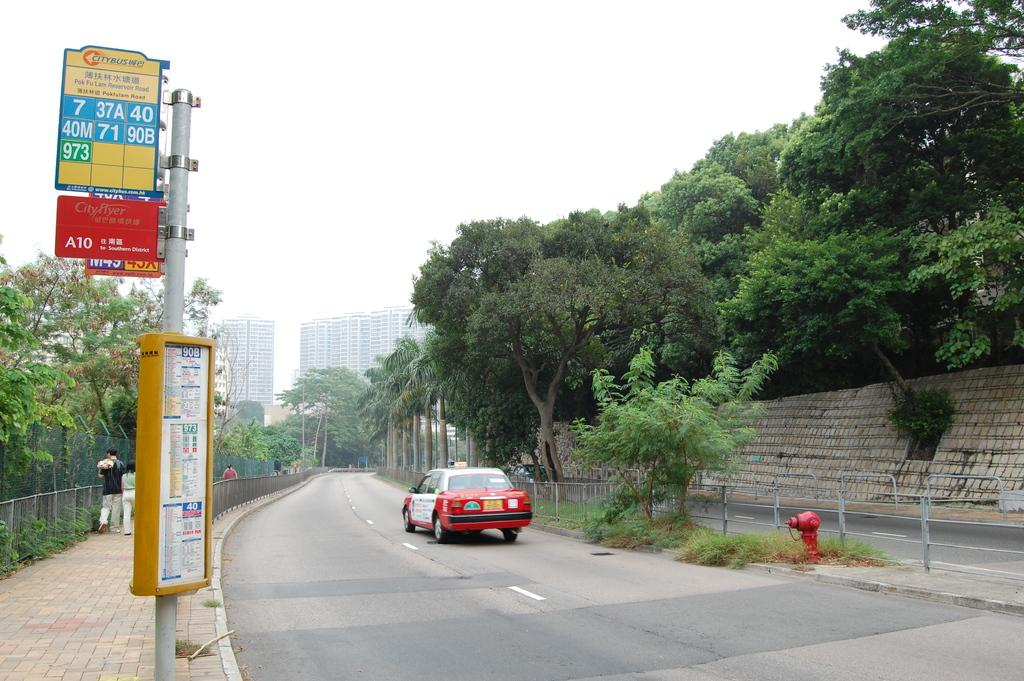<image>
Give a short and clear explanation of the subsequent image. A sign that says No Parking Thursday is on the side of the street in a busy city. 